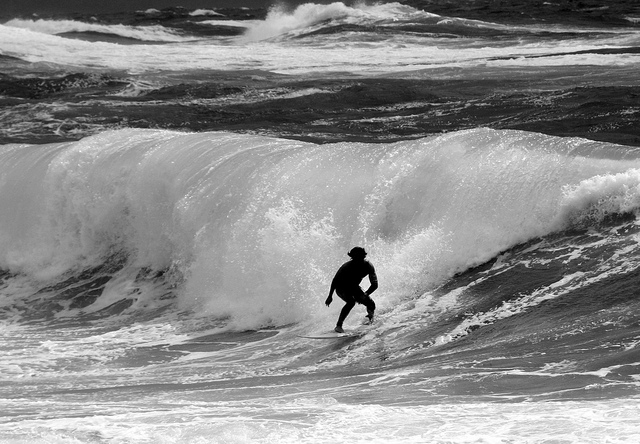How high are the waves? The waves appear formidable, cresting at an estimated height of around 6 feet, providing a thrilling challenge for the surfer. 